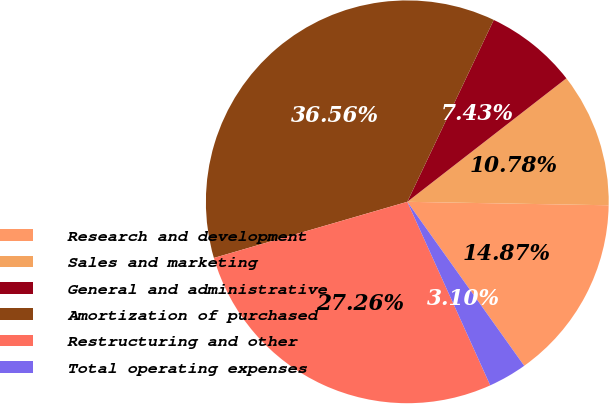Convert chart to OTSL. <chart><loc_0><loc_0><loc_500><loc_500><pie_chart><fcel>Research and development<fcel>Sales and marketing<fcel>General and administrative<fcel>Amortization of purchased<fcel>Restructuring and other<fcel>Total operating expenses<nl><fcel>14.87%<fcel>10.78%<fcel>7.43%<fcel>36.56%<fcel>27.26%<fcel>3.1%<nl></chart> 